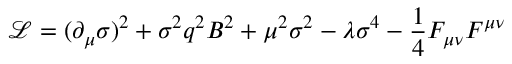Convert formula to latex. <formula><loc_0><loc_0><loc_500><loc_500>\mathcal { L } = ( \partial _ { \mu } \sigma ) ^ { 2 } + \sigma ^ { 2 } q ^ { 2 } B ^ { 2 } + \mu ^ { 2 } \sigma ^ { 2 } - \lambda \sigma ^ { 4 } - \frac { 1 } { 4 } F _ { \mu \nu } F ^ { \mu \nu }</formula> 